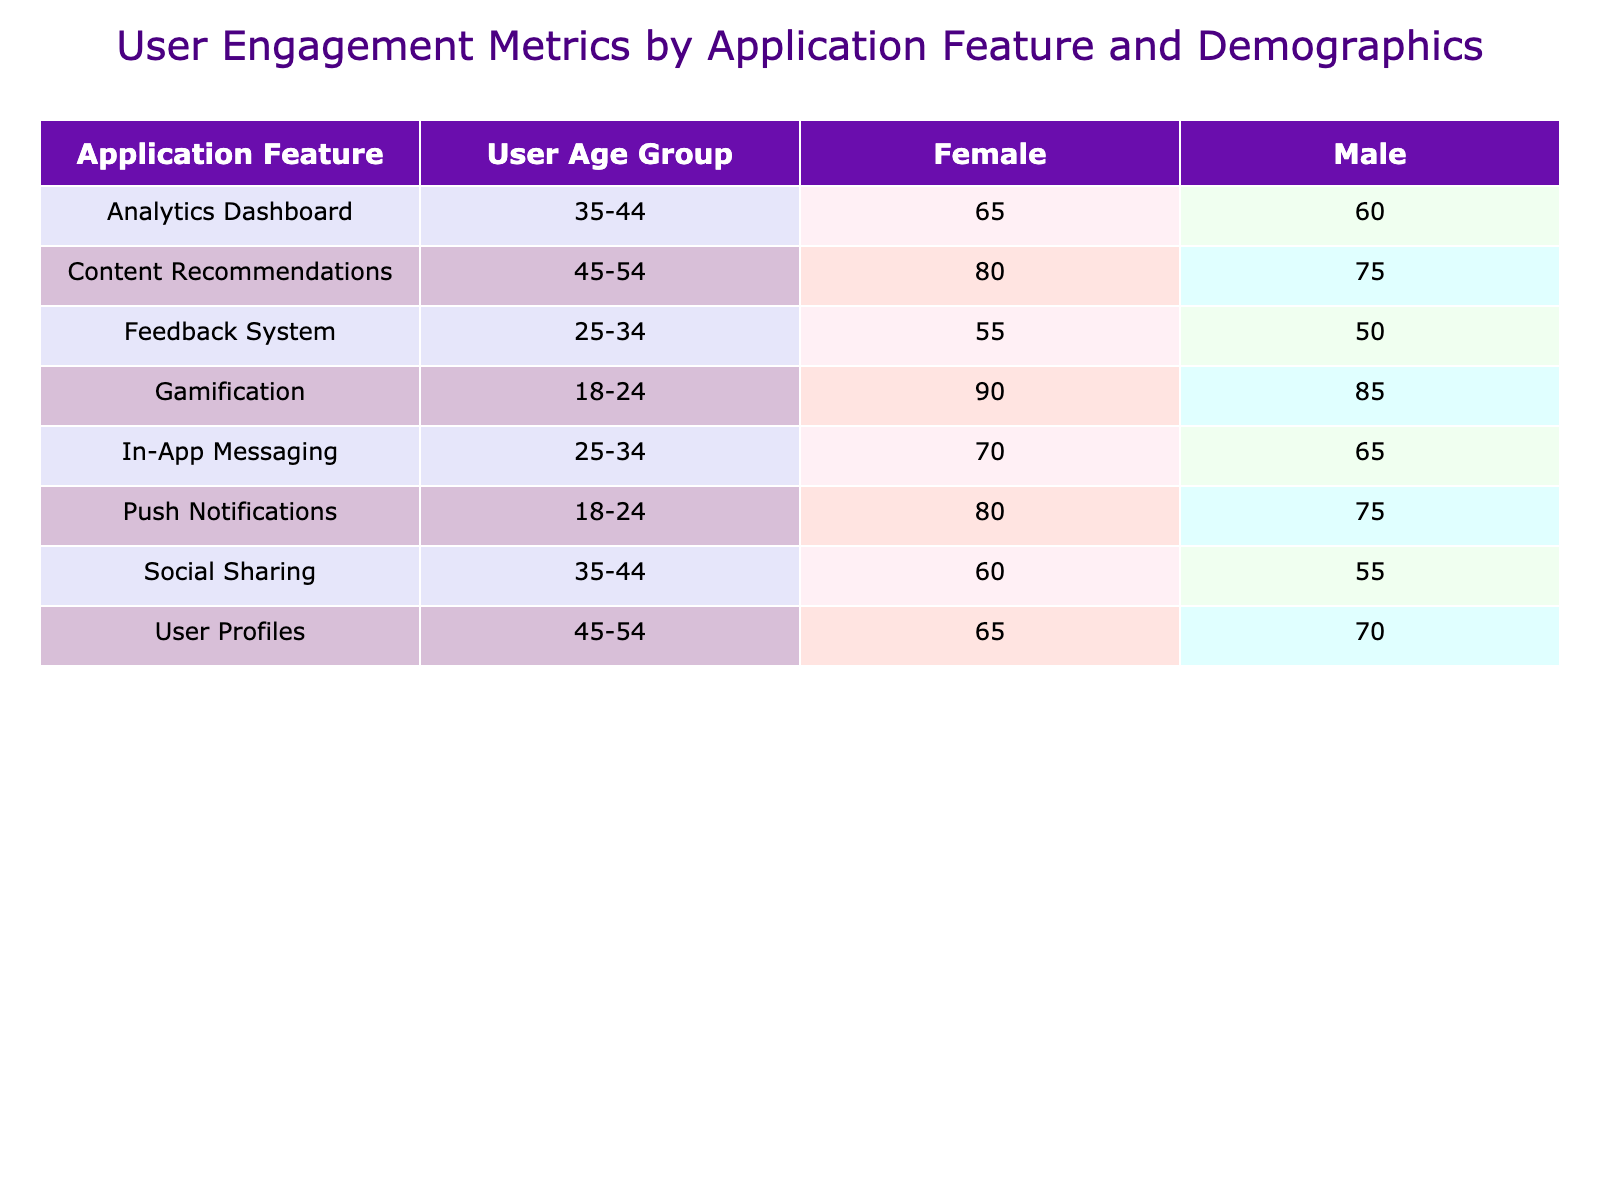What is the engagement score for Female users in Gamification? The table lists the engagement score for Female users under the Gamification application feature, which shows a score of 90.
Answer: 90 What application feature has the highest average engagement score for Male users? By checking the scores for Male users across the application features: Push Notifications (75), In-App Messaging (65), Social Sharing (55), User Profiles (70), Gamification (85), Feedback System (50), Analytics Dashboard (60), and Content Recommendations (75), Gamification has the highest score of 85.
Answer: Gamification What is the average engagement score for Female users in the 25-34 age group? The engagement scores for Female users in the 25-34 age group are 70 (In-App Messaging) and 55 (Feedback System). Summing these gives 70 + 55 = 125, and there are two values, so the average is 125/2 = 62.5.
Answer: 62.5 Is there a gender difference in the engagement score for the Push Notifications feature? For Push Notifications, Male users have a score of 75 and Female users have a score of 80. This means Female users have a higher engagement score compared to Male users.
Answer: Yes What is the total engagement score for Social Sharing across both genders? The engagement score for Social Sharing is 55 for Males and 60 for Females. Adding these scores together gives 55 + 60 = 115.
Answer: 115 Which age group has the lowest average engagement score in User Profiles? For User Profiles, Male users score 70 and Female users score 65. The average is (70 + 65) / 2 = 67.5. This average is lower than that of any other age groups, confirming that 45-54 is the lowest age group in User Profiles.
Answer: 45-54 How does the engagement score for In-App Messaging compare between genders? The scores for In-App Messaging are 65 for Male users and 70 for Female users. Therefore, Female users have a higher engagement score compared to Male users.
Answer: Female users score higher What is the difference in engagement scores between Gamification for Male and Female users? The engagement score for Male users in Gamification is 85, and for Female users, it is 90. Therefore, the difference is 90 - 85 = 5.
Answer: 5 Which feature had the highest average engagement score across all users in the 18-24 age group? For the 18-24 age group, the engagement scores are 75 (Push Notifications - Male), 80 (Push Notifications - Female), 85 (Gamification - Male), and 90 (Gamification - Female). Summing these gives scores of 75 + 80 = 155 for Push Notifications and 85 + 90 = 175 for Gamification, so Gamification had the highest average score.
Answer: Gamification 